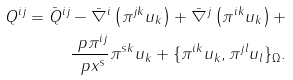Convert formula to latex. <formula><loc_0><loc_0><loc_500><loc_500>Q ^ { i j } = \bar { Q } ^ { i j } - \bar { \nabla } ^ { i } \left ( \pi ^ { j k } u _ { k } \right ) + \bar { \nabla } ^ { j } \left ( \pi ^ { i k } u _ { k } \right ) + \\ \frac { \ p \pi ^ { i j } } { \ p x ^ { s } } \pi ^ { s k } u _ { k } + \{ \pi ^ { i k } u _ { k } , \pi ^ { j l } u _ { l } \} _ { \Omega } .</formula> 